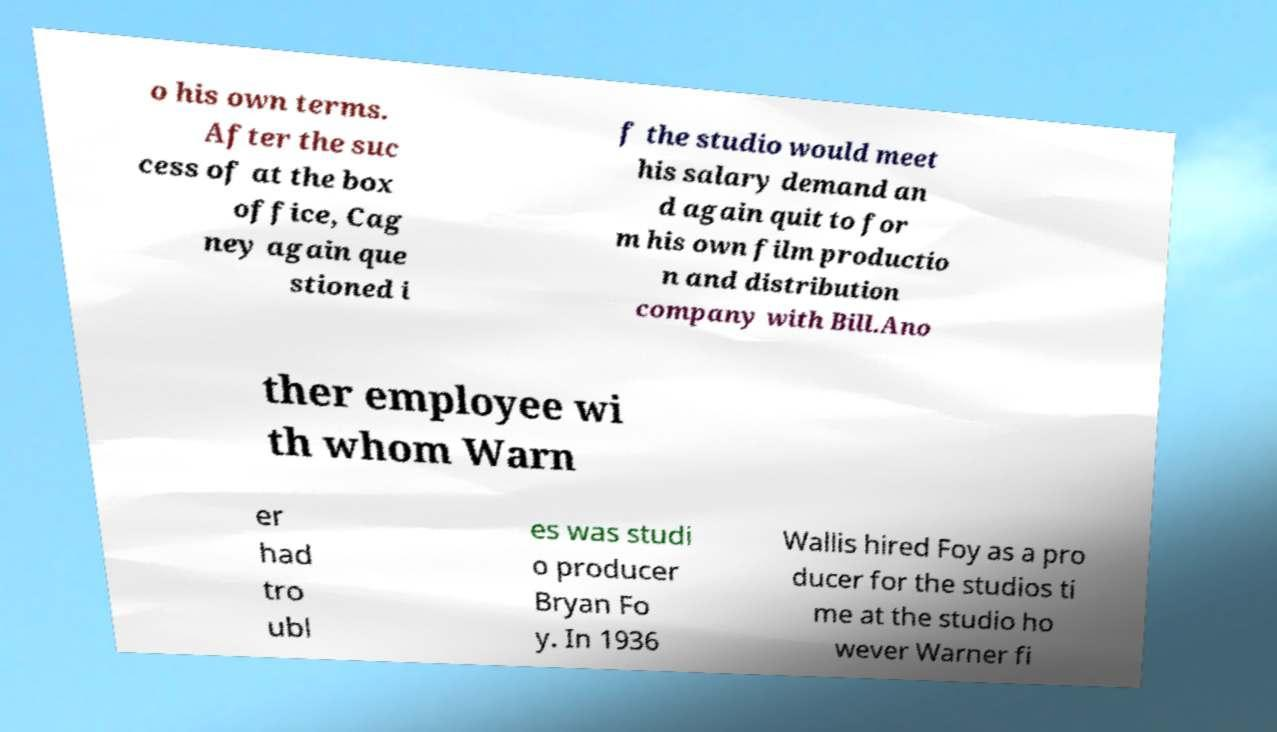Please identify and transcribe the text found in this image. o his own terms. After the suc cess of at the box office, Cag ney again que stioned i f the studio would meet his salary demand an d again quit to for m his own film productio n and distribution company with Bill.Ano ther employee wi th whom Warn er had tro ubl es was studi o producer Bryan Fo y. In 1936 Wallis hired Foy as a pro ducer for the studios ti me at the studio ho wever Warner fi 